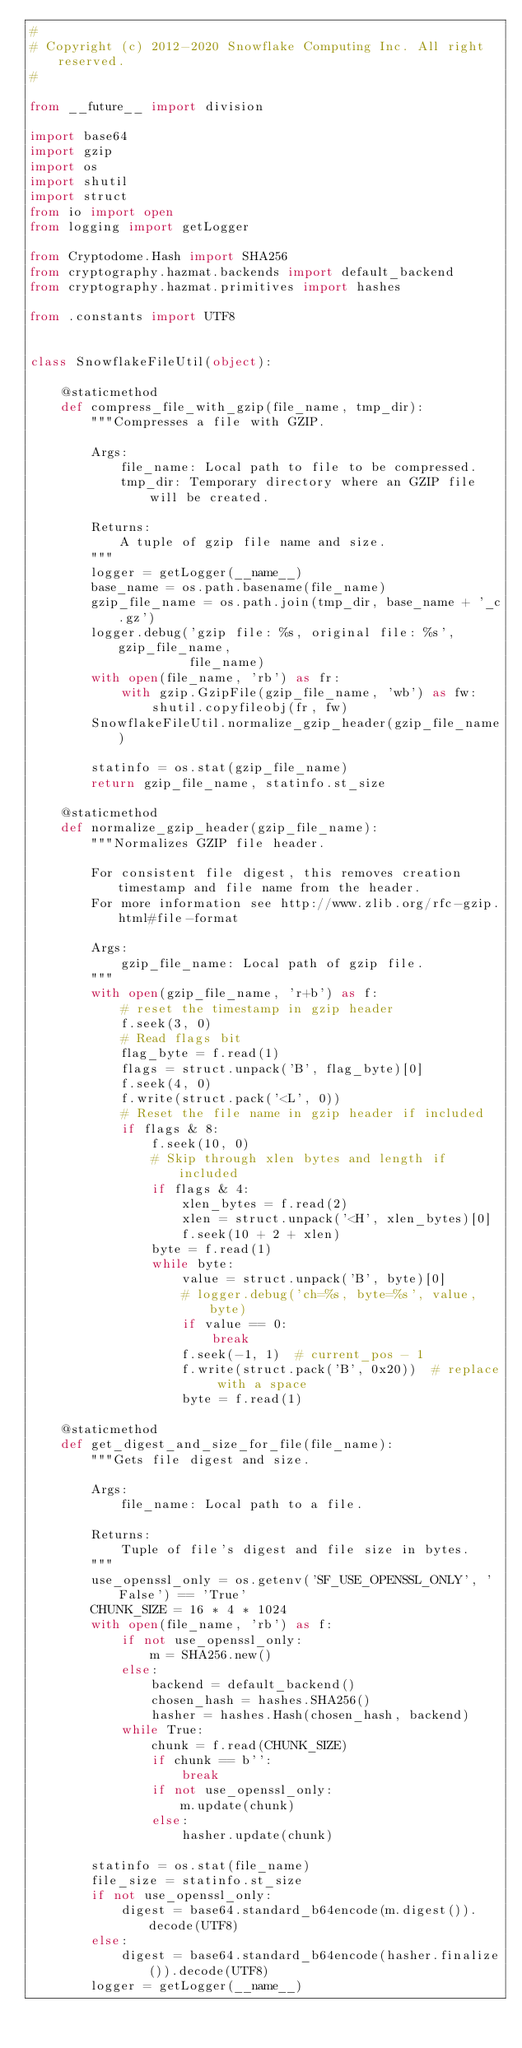Convert code to text. <code><loc_0><loc_0><loc_500><loc_500><_Python_>#
# Copyright (c) 2012-2020 Snowflake Computing Inc. All right reserved.
#

from __future__ import division

import base64
import gzip
import os
import shutil
import struct
from io import open
from logging import getLogger

from Cryptodome.Hash import SHA256
from cryptography.hazmat.backends import default_backend
from cryptography.hazmat.primitives import hashes

from .constants import UTF8


class SnowflakeFileUtil(object):

    @staticmethod
    def compress_file_with_gzip(file_name, tmp_dir):
        """Compresses a file with GZIP.

        Args:
            file_name: Local path to file to be compressed.
            tmp_dir: Temporary directory where an GZIP file will be created.

        Returns:
            A tuple of gzip file name and size.
        """
        logger = getLogger(__name__)
        base_name = os.path.basename(file_name)
        gzip_file_name = os.path.join(tmp_dir, base_name + '_c.gz')
        logger.debug('gzip file: %s, original file: %s', gzip_file_name,
                     file_name)
        with open(file_name, 'rb') as fr:
            with gzip.GzipFile(gzip_file_name, 'wb') as fw:
                shutil.copyfileobj(fr, fw)
        SnowflakeFileUtil.normalize_gzip_header(gzip_file_name)

        statinfo = os.stat(gzip_file_name)
        return gzip_file_name, statinfo.st_size

    @staticmethod
    def normalize_gzip_header(gzip_file_name):
        """Normalizes GZIP file header.

        For consistent file digest, this removes creation timestamp and file name from the header.
        For more information see http://www.zlib.org/rfc-gzip.html#file-format

        Args:
            gzip_file_name: Local path of gzip file.
        """
        with open(gzip_file_name, 'r+b') as f:
            # reset the timestamp in gzip header
            f.seek(3, 0)
            # Read flags bit
            flag_byte = f.read(1)
            flags = struct.unpack('B', flag_byte)[0]
            f.seek(4, 0)
            f.write(struct.pack('<L', 0))
            # Reset the file name in gzip header if included
            if flags & 8:
                f.seek(10, 0)
                # Skip through xlen bytes and length if included
                if flags & 4:
                    xlen_bytes = f.read(2)
                    xlen = struct.unpack('<H', xlen_bytes)[0]
                    f.seek(10 + 2 + xlen)
                byte = f.read(1)
                while byte:
                    value = struct.unpack('B', byte)[0]
                    # logger.debug('ch=%s, byte=%s', value, byte)
                    if value == 0:
                        break
                    f.seek(-1, 1)  # current_pos - 1
                    f.write(struct.pack('B', 0x20))  # replace with a space
                    byte = f.read(1)

    @staticmethod
    def get_digest_and_size_for_file(file_name):
        """Gets file digest and size.

        Args:
            file_name: Local path to a file.

        Returns:
            Tuple of file's digest and file size in bytes.
        """
        use_openssl_only = os.getenv('SF_USE_OPENSSL_ONLY', 'False') == 'True'
        CHUNK_SIZE = 16 * 4 * 1024
        with open(file_name, 'rb') as f:
            if not use_openssl_only:
                m = SHA256.new()
            else:
                backend = default_backend()
                chosen_hash = hashes.SHA256()
                hasher = hashes.Hash(chosen_hash, backend)
            while True:
                chunk = f.read(CHUNK_SIZE)
                if chunk == b'':
                    break
                if not use_openssl_only:
                    m.update(chunk)
                else:
                    hasher.update(chunk)

        statinfo = os.stat(file_name)
        file_size = statinfo.st_size
        if not use_openssl_only:
            digest = base64.standard_b64encode(m.digest()).decode(UTF8)
        else:
            digest = base64.standard_b64encode(hasher.finalize()).decode(UTF8)
        logger = getLogger(__name__)</code> 